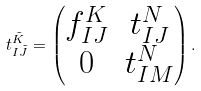Convert formula to latex. <formula><loc_0><loc_0><loc_500><loc_500>t _ { I \tilde { J } } ^ { \tilde { K } } = \begin{pmatrix} f _ { I J } ^ { K } & t _ { I J } ^ { N } \\ 0 & t _ { I M } ^ { N } \\ \end{pmatrix} .</formula> 